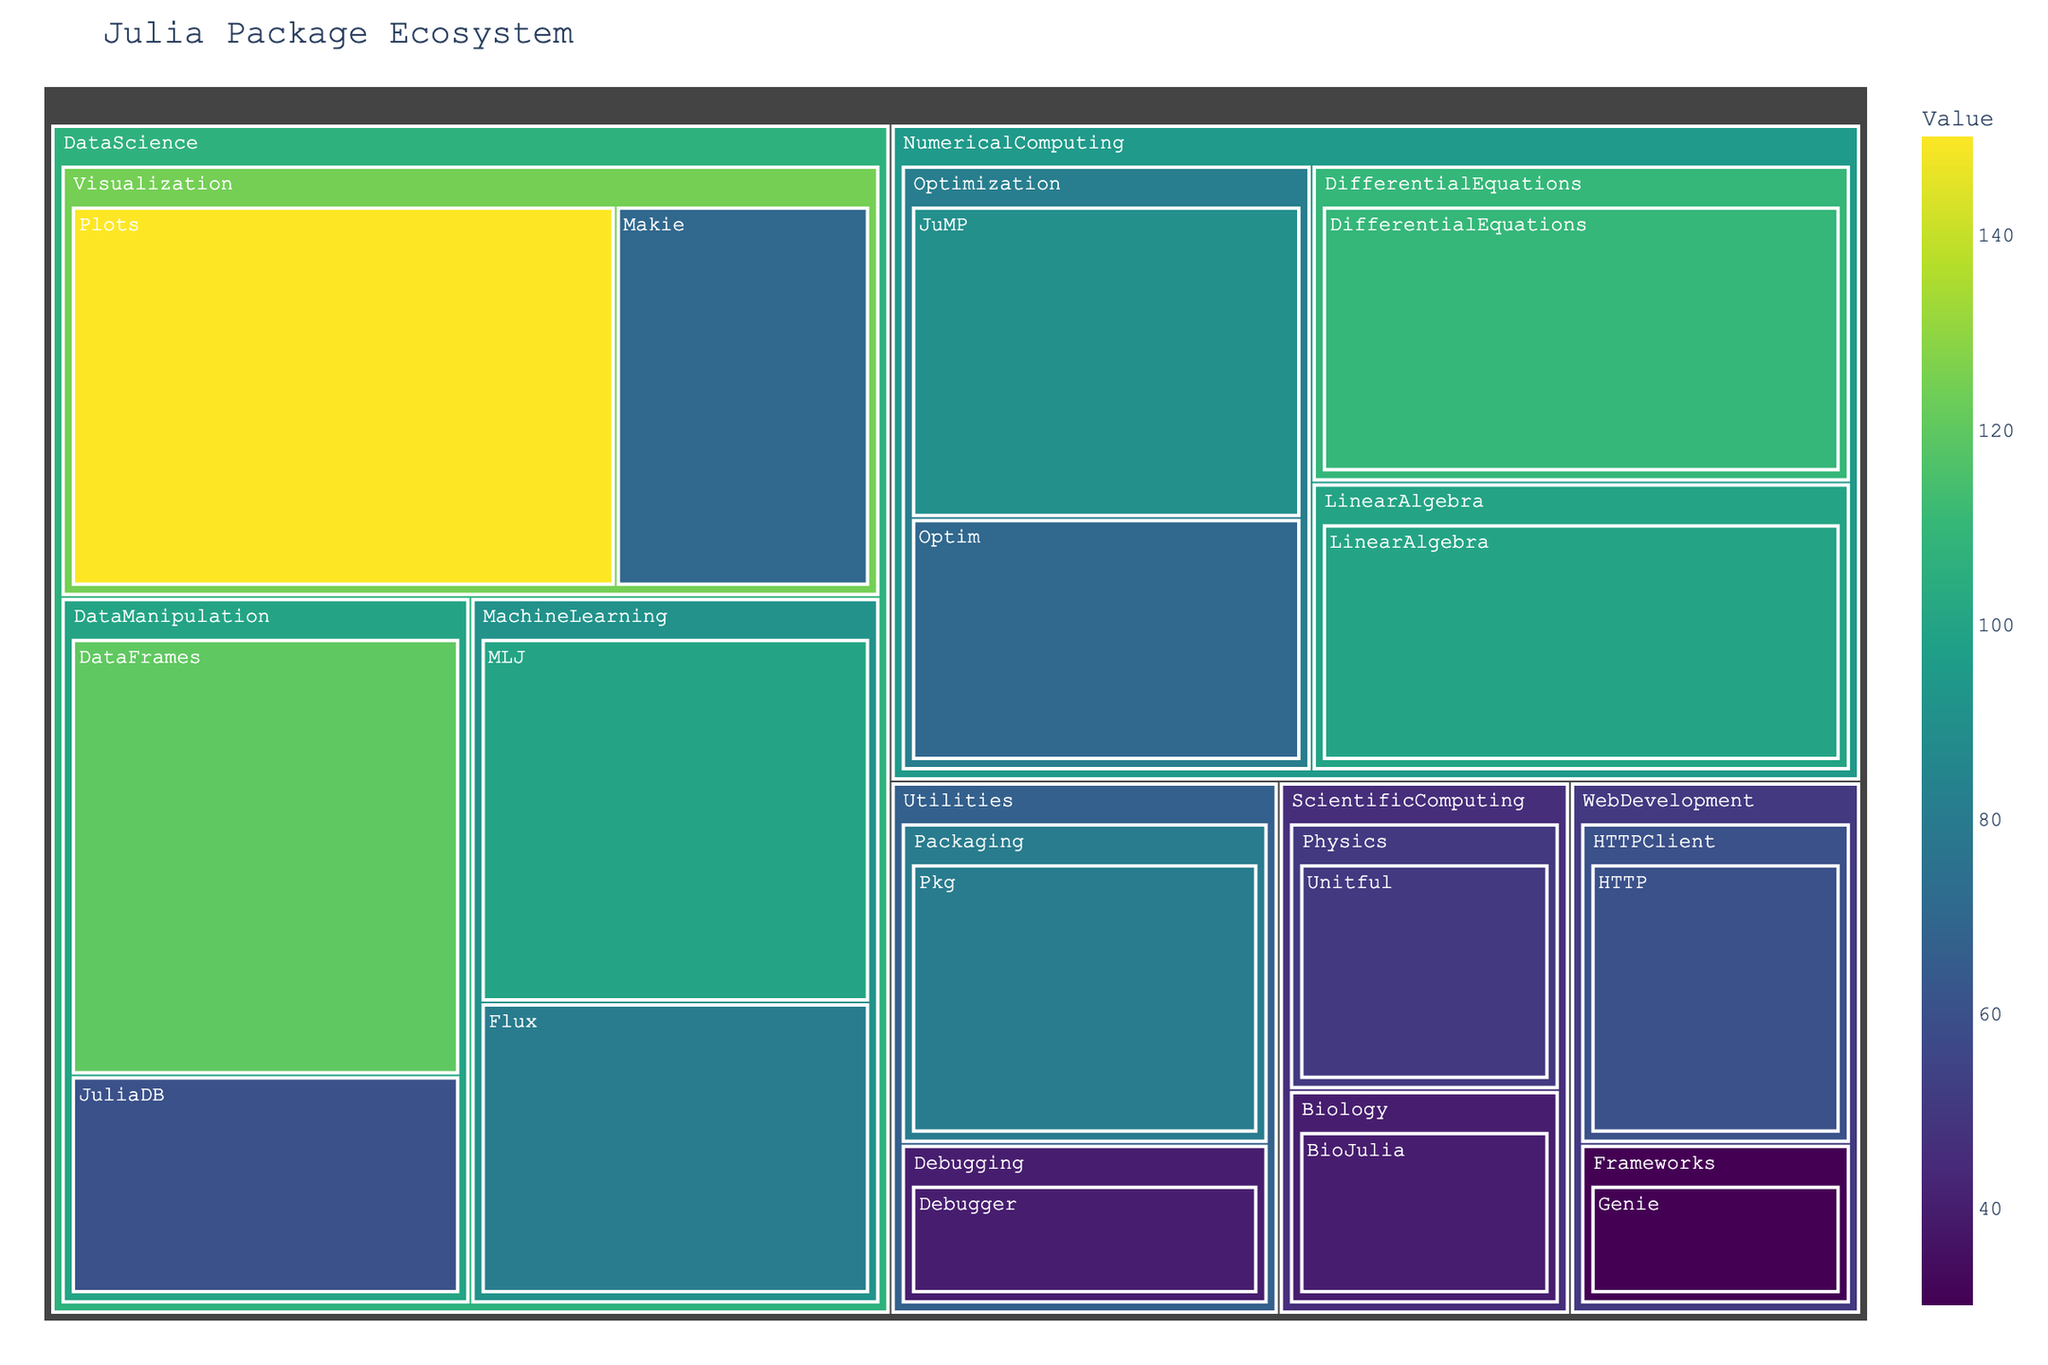What's the largest subcategory in the DataScience category? To find the largest subcategory in DataScience, sum the package values in each subcategory: MachineLearning (MLJ: 100 + Flux: 80 = 180), DataManipulation (DataFrames: 120 + JuliaDB: 60 = 180), Visualization (Plots: 150 + Makie: 70 = 220). The largest subcategory is Visualization with a value of 220.
Answer: Visualization Which package has the highest value? Look at the package values in the figure. The package with the highest value is Plots with a value of 150.
Answer: Plots How many categories are there in the treemap? Count the number of distinct categories listed in the figure's treemap. There are DataScience, NumericalComputing, ScientificComputing, WebDevelopment, and Utilities. So, there are 5 categories.
Answer: 5 What's the difference in value between the DataFrames and JuliaDB packages? Find the values of DataFrames and JuliaDB. DataFrames has a value of 120, and JuliaDB has a value of 60. The difference is 120 - 60 = 60.
Answer: 60 Which category has the lowest total value? Sum the package values in each category. DataScience (DataManipulation: 120 + 60, MachineLearning: 100 + 80, Visualization: 150 + 70), NumericalComputing (Optimization: 90 + 70, DifferentialEquations: 110, LinearAlgebra: 100), ScientificComputing (Physics: 50, Biology: 40), WebDevelopment (Frameworks: 30, HTTPClient: 60), Utilities (Debugging: 40, Packaging: 80). The lowest total is in ScientificComputing with 50 + 40 = 90.
Answer: ScientificComputing What is the ratio of the value of MLJ to Flux in DataScience? The values of MLJ and Flux are 100 and 80 respectively. The ratio is 100/80 which simplifies to 5/4.
Answer: 5:4 Which subcategory in NumericalComputing has the most packages? Count the number of packages in each subcategory of NumericalComputing: Optimization (2), DifferentialEquations (1), LinearAlgebra (1). The Optimization subcategory has the most packages with 2.
Answer: Optimization How does the value of the Pkg package compare to the Debbuger package? The value of the Pkg package is 80 and Debugger is 40. Pkg has a higher value than Debugger.
Answer: Pkg has a higher value What is the total value of all packages in the WebDevelopment category? Sum the values of all packages in the WebDevelopment category: Genie (30) and HTTP (60). Total value = 30 + 60 = 90.
Answer: 90 What percentage of the total value in DataScience does the Plots package represent? The total value in DataScience is the sum of its subcategories: MachineLearning (100 + 80), DataManipulation (120 + 60), Visualization (150 + 70). Total = 480. The value of Plots is 150. The percentage is (150/480)*100 ≈ 31.25%.
Answer: 31.25% 